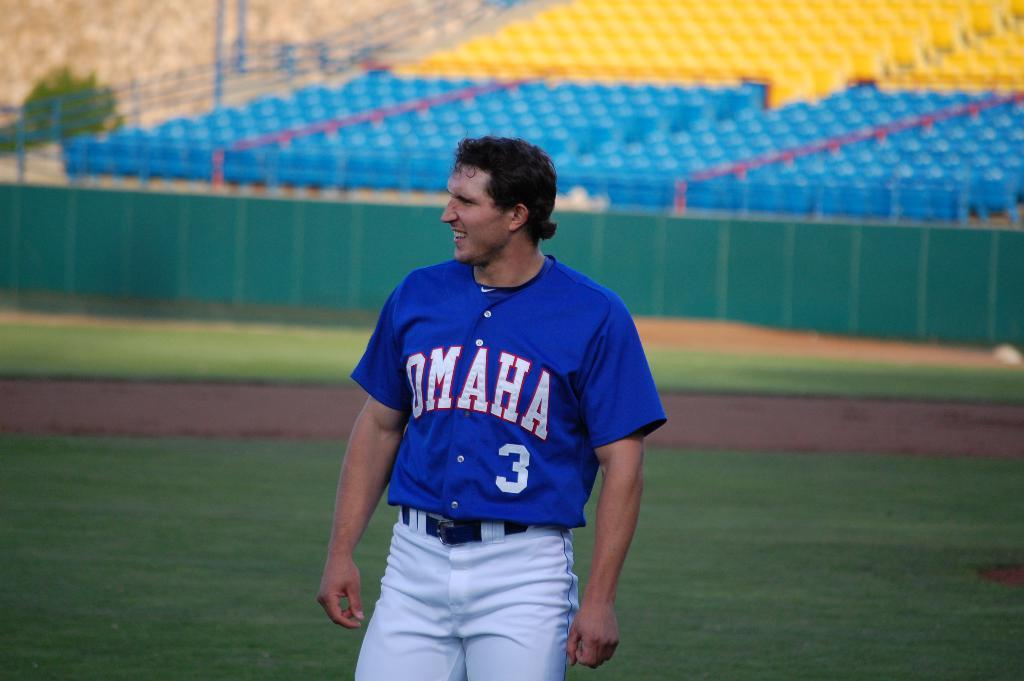Provide a one-sentence caption for the provided image. A PLAYER FOR OMAHA IN A BLUE JERSEY NUMBERED THREE ON THE FIELD. 